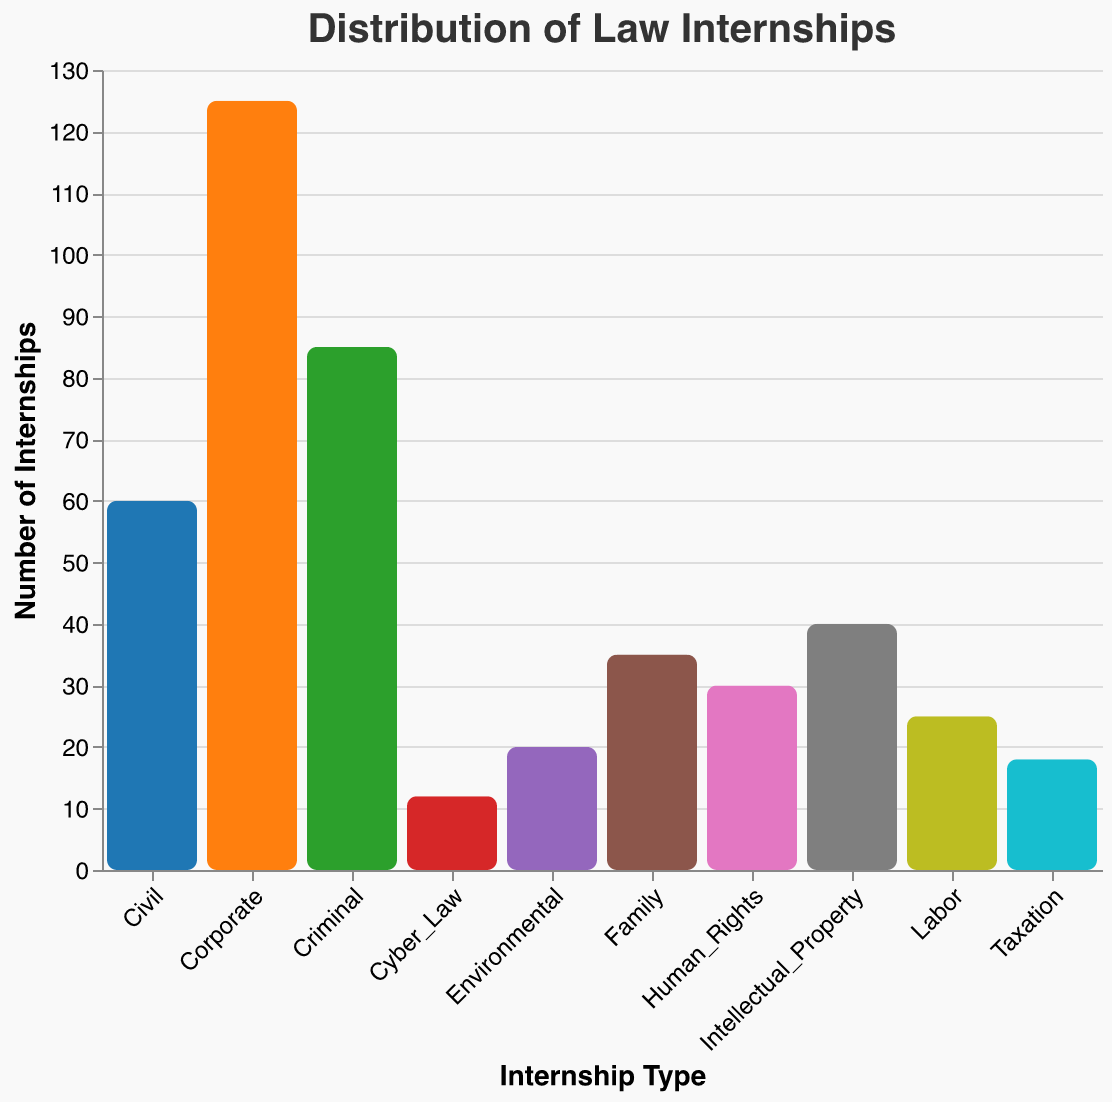Which type of law internship has the highest number of internships? The bar representing the "Corporate" internship is the tallest in the bar plot, indicating that it has the highest number of internships.
Answer: Corporate Which type of law internship has the lowest number of internships? The bar representing the "Cyber_Law" internship is the shortest in the bar plot, indicating that it has the lowest number of internships.
Answer: Cyber_Law How many more Corporate internships are there compared to Civil internships? The number of Corporate internships is 125, and the number of Civil internships is 60. The difference is 125 - 60.
Answer: 65 What is the sum of the number of internships for Human Rights, Environmental, and Labor categories? The number of Human Rights internships is 30, Environmental internships is 20, and Labor internships is 25. Their sum is 30 + 20 + 25.
Answer: 75 Which type of law internship has more internships: Family or Taxation? The bar representing "Family" is taller than the bar representing "Taxation." Therefore, Family has more internships.
Answer: Family How many types of internships have fewer than 50 internships? By observing the bar lengths, internships with fewer than 50 internships are Intellectual_Property (40), Human_Rights (30), Environmental (20), Labor (25), Taxation (18), Family (35), and Cyber_Law (12). Counting these categories gives us 7 types.
Answer: 7 Which internship types have between 30 and 60 internships inclusive? By inspecting the bar lengths, the categories between 30 and 60 are Civil (60), Intellectual_Property (40), Human_Rights (30), and Family (35).
Answer: Civil, Intellectual_Property, Human_Rights, Family What is the total number of internships across all types? Adding the number of internships from all categories: 125 + 85 + 60 + 40 + 30 + 20 + 25 + 18 + 35 + 12.
Answer: 450 Which has fewer internships: Criminal or Intellectual_Property? By comparing the bars, Criminal internships are 85 and Intellectual_Property internships are 40. Intellectual_Property has fewer internships.
Answer: Intellectual_Property What is the average number of internships across all types? The total number of internships is 450, distributed across 10 internship types. The average is 450 divided by 10.
Answer: 45 